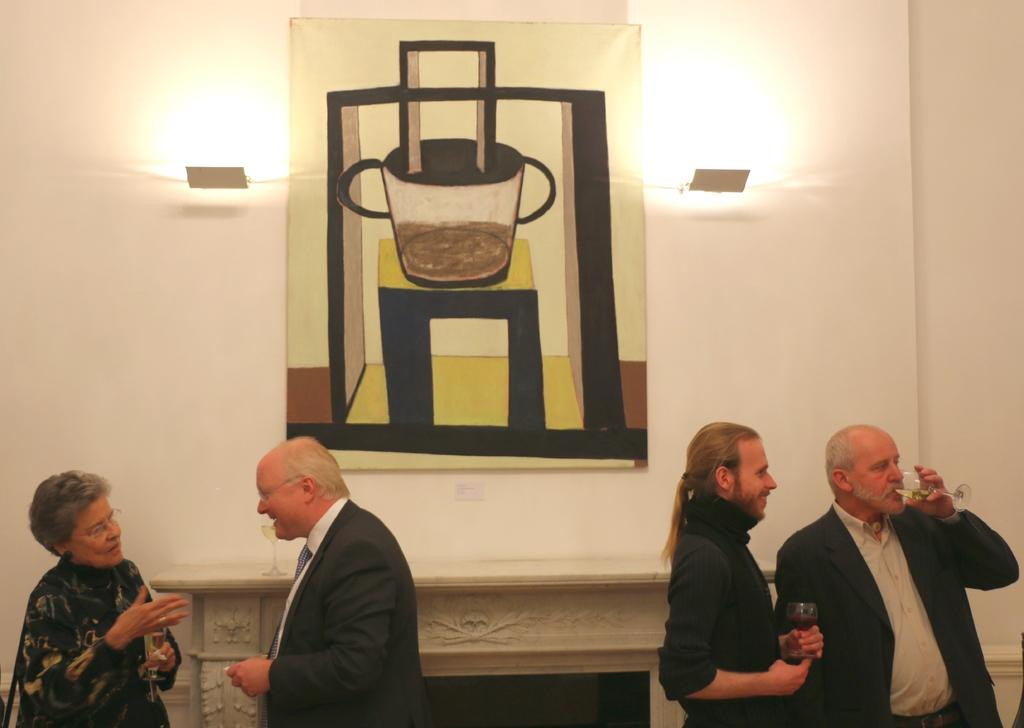How many people are in the image? There are persons in the image. What are the persons holding in their hands? Three persons are holding glasses with liquid in them. What can be seen in the background of the image? There is a board and lights on the wall in the background of the image. What type of drug is being administered to the sisters in the image? There is no mention of sisters or any drug in the image; it features persons holding glasses with liquid. 